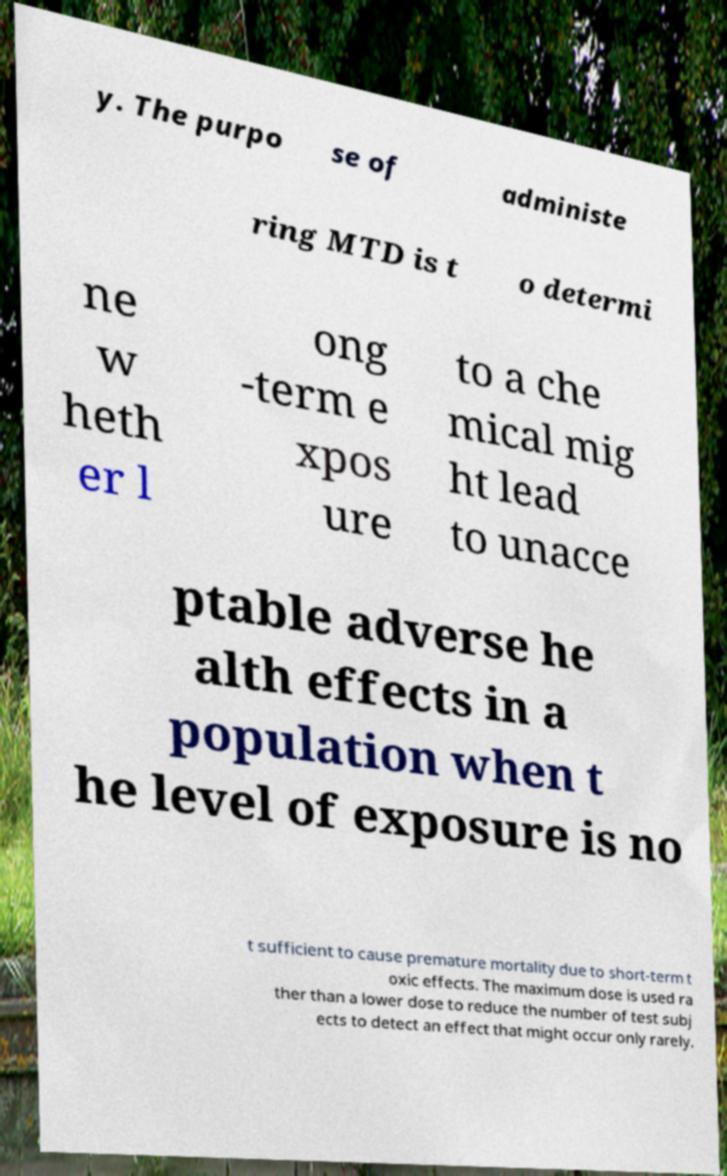Please identify and transcribe the text found in this image. y. The purpo se of administe ring MTD is t o determi ne w heth er l ong -term e xpos ure to a che mical mig ht lead to unacce ptable adverse he alth effects in a population when t he level of exposure is no t sufficient to cause premature mortality due to short-term t oxic effects. The maximum dose is used ra ther than a lower dose to reduce the number of test subj ects to detect an effect that might occur only rarely. 